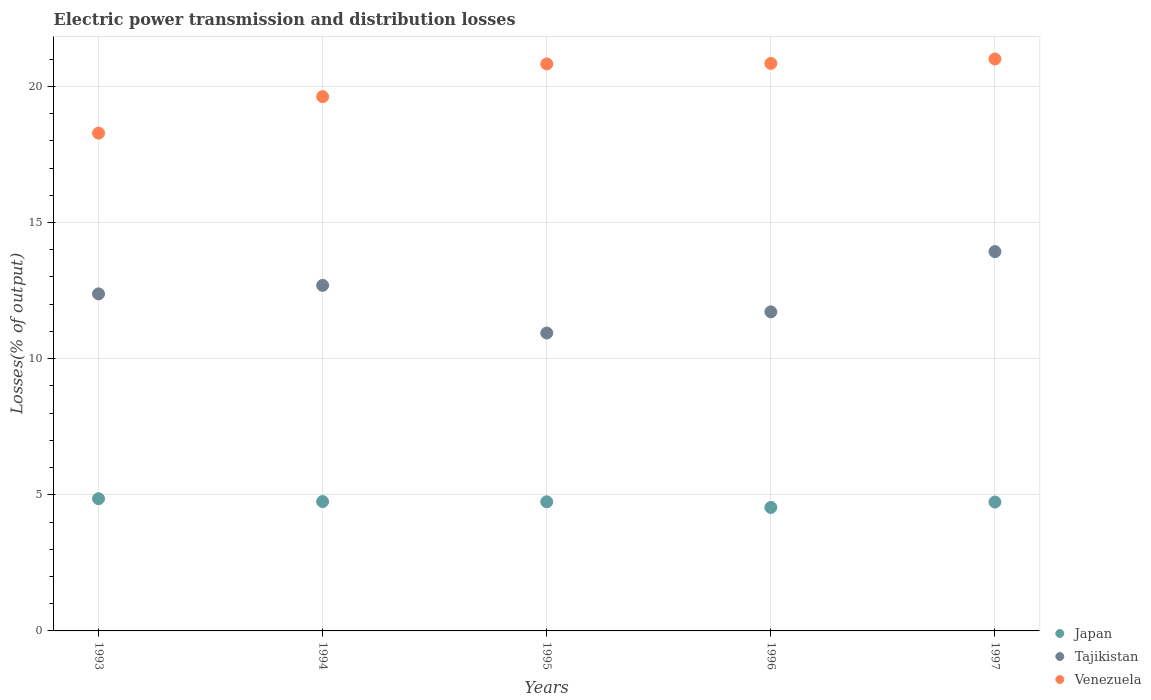How many different coloured dotlines are there?
Your response must be concise. 3. Is the number of dotlines equal to the number of legend labels?
Your response must be concise. Yes. What is the electric power transmission and distribution losses in Tajikistan in 1993?
Your answer should be compact. 12.38. Across all years, what is the maximum electric power transmission and distribution losses in Venezuela?
Provide a succinct answer. 21. Across all years, what is the minimum electric power transmission and distribution losses in Tajikistan?
Ensure brevity in your answer.  10.94. What is the total electric power transmission and distribution losses in Venezuela in the graph?
Offer a terse response. 100.57. What is the difference between the electric power transmission and distribution losses in Venezuela in 1994 and that in 1995?
Ensure brevity in your answer.  -1.2. What is the difference between the electric power transmission and distribution losses in Venezuela in 1993 and the electric power transmission and distribution losses in Tajikistan in 1997?
Keep it short and to the point. 4.35. What is the average electric power transmission and distribution losses in Tajikistan per year?
Make the answer very short. 12.33. In the year 1996, what is the difference between the electric power transmission and distribution losses in Venezuela and electric power transmission and distribution losses in Japan?
Give a very brief answer. 16.31. What is the ratio of the electric power transmission and distribution losses in Tajikistan in 1995 to that in 1996?
Your answer should be very brief. 0.93. Is the electric power transmission and distribution losses in Venezuela in 1994 less than that in 1997?
Your answer should be very brief. Yes. What is the difference between the highest and the second highest electric power transmission and distribution losses in Venezuela?
Give a very brief answer. 0.16. What is the difference between the highest and the lowest electric power transmission and distribution losses in Japan?
Your response must be concise. 0.32. In how many years, is the electric power transmission and distribution losses in Tajikistan greater than the average electric power transmission and distribution losses in Tajikistan taken over all years?
Your response must be concise. 3. Is the sum of the electric power transmission and distribution losses in Tajikistan in 1994 and 1996 greater than the maximum electric power transmission and distribution losses in Japan across all years?
Your response must be concise. Yes. How many dotlines are there?
Your response must be concise. 3. How many years are there in the graph?
Your answer should be very brief. 5. What is the difference between two consecutive major ticks on the Y-axis?
Ensure brevity in your answer.  5. Does the graph contain grids?
Provide a short and direct response. Yes. Where does the legend appear in the graph?
Your answer should be compact. Bottom right. How are the legend labels stacked?
Provide a short and direct response. Vertical. What is the title of the graph?
Your response must be concise. Electric power transmission and distribution losses. Does "Slovenia" appear as one of the legend labels in the graph?
Offer a terse response. No. What is the label or title of the X-axis?
Provide a succinct answer. Years. What is the label or title of the Y-axis?
Offer a very short reply. Losses(% of output). What is the Losses(% of output) of Japan in 1993?
Ensure brevity in your answer.  4.86. What is the Losses(% of output) in Tajikistan in 1993?
Provide a short and direct response. 12.38. What is the Losses(% of output) of Venezuela in 1993?
Ensure brevity in your answer.  18.28. What is the Losses(% of output) of Japan in 1994?
Offer a very short reply. 4.75. What is the Losses(% of output) of Tajikistan in 1994?
Provide a short and direct response. 12.69. What is the Losses(% of output) in Venezuela in 1994?
Provide a short and direct response. 19.62. What is the Losses(% of output) in Japan in 1995?
Your answer should be very brief. 4.74. What is the Losses(% of output) in Tajikistan in 1995?
Your answer should be very brief. 10.94. What is the Losses(% of output) in Venezuela in 1995?
Keep it short and to the point. 20.82. What is the Losses(% of output) of Japan in 1996?
Make the answer very short. 4.54. What is the Losses(% of output) in Tajikistan in 1996?
Ensure brevity in your answer.  11.72. What is the Losses(% of output) in Venezuela in 1996?
Your answer should be compact. 20.84. What is the Losses(% of output) of Japan in 1997?
Your response must be concise. 4.73. What is the Losses(% of output) in Tajikistan in 1997?
Your response must be concise. 13.93. What is the Losses(% of output) in Venezuela in 1997?
Make the answer very short. 21. Across all years, what is the maximum Losses(% of output) of Japan?
Offer a terse response. 4.86. Across all years, what is the maximum Losses(% of output) in Tajikistan?
Your answer should be very brief. 13.93. Across all years, what is the maximum Losses(% of output) of Venezuela?
Provide a short and direct response. 21. Across all years, what is the minimum Losses(% of output) in Japan?
Offer a terse response. 4.54. Across all years, what is the minimum Losses(% of output) in Tajikistan?
Give a very brief answer. 10.94. Across all years, what is the minimum Losses(% of output) in Venezuela?
Offer a terse response. 18.28. What is the total Losses(% of output) in Japan in the graph?
Your response must be concise. 23.62. What is the total Losses(% of output) in Tajikistan in the graph?
Your answer should be compact. 61.66. What is the total Losses(% of output) of Venezuela in the graph?
Keep it short and to the point. 100.57. What is the difference between the Losses(% of output) of Japan in 1993 and that in 1994?
Provide a short and direct response. 0.11. What is the difference between the Losses(% of output) of Tajikistan in 1993 and that in 1994?
Ensure brevity in your answer.  -0.31. What is the difference between the Losses(% of output) of Venezuela in 1993 and that in 1994?
Give a very brief answer. -1.34. What is the difference between the Losses(% of output) in Japan in 1993 and that in 1995?
Provide a short and direct response. 0.11. What is the difference between the Losses(% of output) in Tajikistan in 1993 and that in 1995?
Your answer should be very brief. 1.44. What is the difference between the Losses(% of output) in Venezuela in 1993 and that in 1995?
Offer a terse response. -2.54. What is the difference between the Losses(% of output) in Japan in 1993 and that in 1996?
Provide a succinct answer. 0.32. What is the difference between the Losses(% of output) in Tajikistan in 1993 and that in 1996?
Offer a terse response. 0.66. What is the difference between the Losses(% of output) in Venezuela in 1993 and that in 1996?
Your answer should be compact. -2.56. What is the difference between the Losses(% of output) of Japan in 1993 and that in 1997?
Make the answer very short. 0.12. What is the difference between the Losses(% of output) in Tajikistan in 1993 and that in 1997?
Ensure brevity in your answer.  -1.55. What is the difference between the Losses(% of output) in Venezuela in 1993 and that in 1997?
Offer a terse response. -2.72. What is the difference between the Losses(% of output) in Japan in 1994 and that in 1995?
Offer a very short reply. 0.01. What is the difference between the Losses(% of output) in Tajikistan in 1994 and that in 1995?
Provide a succinct answer. 1.75. What is the difference between the Losses(% of output) in Venezuela in 1994 and that in 1995?
Make the answer very short. -1.2. What is the difference between the Losses(% of output) of Japan in 1994 and that in 1996?
Provide a succinct answer. 0.21. What is the difference between the Losses(% of output) of Tajikistan in 1994 and that in 1996?
Keep it short and to the point. 0.97. What is the difference between the Losses(% of output) of Venezuela in 1994 and that in 1996?
Offer a terse response. -1.22. What is the difference between the Losses(% of output) of Japan in 1994 and that in 1997?
Your answer should be compact. 0.02. What is the difference between the Losses(% of output) of Tajikistan in 1994 and that in 1997?
Offer a terse response. -1.24. What is the difference between the Losses(% of output) of Venezuela in 1994 and that in 1997?
Offer a very short reply. -1.38. What is the difference between the Losses(% of output) of Japan in 1995 and that in 1996?
Provide a succinct answer. 0.21. What is the difference between the Losses(% of output) in Tajikistan in 1995 and that in 1996?
Provide a succinct answer. -0.78. What is the difference between the Losses(% of output) of Venezuela in 1995 and that in 1996?
Your response must be concise. -0.02. What is the difference between the Losses(% of output) of Japan in 1995 and that in 1997?
Offer a terse response. 0.01. What is the difference between the Losses(% of output) in Tajikistan in 1995 and that in 1997?
Ensure brevity in your answer.  -2.99. What is the difference between the Losses(% of output) of Venezuela in 1995 and that in 1997?
Provide a succinct answer. -0.18. What is the difference between the Losses(% of output) of Japan in 1996 and that in 1997?
Keep it short and to the point. -0.2. What is the difference between the Losses(% of output) of Tajikistan in 1996 and that in 1997?
Your response must be concise. -2.21. What is the difference between the Losses(% of output) in Venezuela in 1996 and that in 1997?
Your answer should be compact. -0.16. What is the difference between the Losses(% of output) of Japan in 1993 and the Losses(% of output) of Tajikistan in 1994?
Your response must be concise. -7.83. What is the difference between the Losses(% of output) of Japan in 1993 and the Losses(% of output) of Venezuela in 1994?
Offer a very short reply. -14.77. What is the difference between the Losses(% of output) in Tajikistan in 1993 and the Losses(% of output) in Venezuela in 1994?
Provide a succinct answer. -7.24. What is the difference between the Losses(% of output) of Japan in 1993 and the Losses(% of output) of Tajikistan in 1995?
Provide a succinct answer. -6.09. What is the difference between the Losses(% of output) of Japan in 1993 and the Losses(% of output) of Venezuela in 1995?
Offer a very short reply. -15.97. What is the difference between the Losses(% of output) of Tajikistan in 1993 and the Losses(% of output) of Venezuela in 1995?
Your response must be concise. -8.45. What is the difference between the Losses(% of output) in Japan in 1993 and the Losses(% of output) in Tajikistan in 1996?
Make the answer very short. -6.86. What is the difference between the Losses(% of output) of Japan in 1993 and the Losses(% of output) of Venezuela in 1996?
Your answer should be very brief. -15.99. What is the difference between the Losses(% of output) of Tajikistan in 1993 and the Losses(% of output) of Venezuela in 1996?
Make the answer very short. -8.46. What is the difference between the Losses(% of output) of Japan in 1993 and the Losses(% of output) of Tajikistan in 1997?
Offer a terse response. -9.08. What is the difference between the Losses(% of output) in Japan in 1993 and the Losses(% of output) in Venezuela in 1997?
Provide a short and direct response. -16.15. What is the difference between the Losses(% of output) of Tajikistan in 1993 and the Losses(% of output) of Venezuela in 1997?
Make the answer very short. -8.63. What is the difference between the Losses(% of output) of Japan in 1994 and the Losses(% of output) of Tajikistan in 1995?
Ensure brevity in your answer.  -6.19. What is the difference between the Losses(% of output) in Japan in 1994 and the Losses(% of output) in Venezuela in 1995?
Provide a succinct answer. -16.07. What is the difference between the Losses(% of output) in Tajikistan in 1994 and the Losses(% of output) in Venezuela in 1995?
Make the answer very short. -8.13. What is the difference between the Losses(% of output) of Japan in 1994 and the Losses(% of output) of Tajikistan in 1996?
Provide a short and direct response. -6.97. What is the difference between the Losses(% of output) of Japan in 1994 and the Losses(% of output) of Venezuela in 1996?
Provide a succinct answer. -16.09. What is the difference between the Losses(% of output) of Tajikistan in 1994 and the Losses(% of output) of Venezuela in 1996?
Provide a succinct answer. -8.15. What is the difference between the Losses(% of output) of Japan in 1994 and the Losses(% of output) of Tajikistan in 1997?
Offer a terse response. -9.18. What is the difference between the Losses(% of output) of Japan in 1994 and the Losses(% of output) of Venezuela in 1997?
Give a very brief answer. -16.25. What is the difference between the Losses(% of output) of Tajikistan in 1994 and the Losses(% of output) of Venezuela in 1997?
Make the answer very short. -8.31. What is the difference between the Losses(% of output) in Japan in 1995 and the Losses(% of output) in Tajikistan in 1996?
Give a very brief answer. -6.98. What is the difference between the Losses(% of output) of Japan in 1995 and the Losses(% of output) of Venezuela in 1996?
Ensure brevity in your answer.  -16.1. What is the difference between the Losses(% of output) in Tajikistan in 1995 and the Losses(% of output) in Venezuela in 1996?
Keep it short and to the point. -9.9. What is the difference between the Losses(% of output) in Japan in 1995 and the Losses(% of output) in Tajikistan in 1997?
Your response must be concise. -9.19. What is the difference between the Losses(% of output) in Japan in 1995 and the Losses(% of output) in Venezuela in 1997?
Offer a very short reply. -16.26. What is the difference between the Losses(% of output) in Tajikistan in 1995 and the Losses(% of output) in Venezuela in 1997?
Give a very brief answer. -10.06. What is the difference between the Losses(% of output) in Japan in 1996 and the Losses(% of output) in Tajikistan in 1997?
Your response must be concise. -9.4. What is the difference between the Losses(% of output) in Japan in 1996 and the Losses(% of output) in Venezuela in 1997?
Your response must be concise. -16.47. What is the difference between the Losses(% of output) in Tajikistan in 1996 and the Losses(% of output) in Venezuela in 1997?
Make the answer very short. -9.29. What is the average Losses(% of output) in Japan per year?
Make the answer very short. 4.72. What is the average Losses(% of output) of Tajikistan per year?
Provide a short and direct response. 12.33. What is the average Losses(% of output) of Venezuela per year?
Keep it short and to the point. 20.11. In the year 1993, what is the difference between the Losses(% of output) of Japan and Losses(% of output) of Tajikistan?
Your answer should be very brief. -7.52. In the year 1993, what is the difference between the Losses(% of output) in Japan and Losses(% of output) in Venezuela?
Your answer should be compact. -13.43. In the year 1993, what is the difference between the Losses(% of output) of Tajikistan and Losses(% of output) of Venezuela?
Provide a short and direct response. -5.9. In the year 1994, what is the difference between the Losses(% of output) in Japan and Losses(% of output) in Tajikistan?
Your answer should be compact. -7.94. In the year 1994, what is the difference between the Losses(% of output) in Japan and Losses(% of output) in Venezuela?
Your response must be concise. -14.87. In the year 1994, what is the difference between the Losses(% of output) of Tajikistan and Losses(% of output) of Venezuela?
Your answer should be very brief. -6.93. In the year 1995, what is the difference between the Losses(% of output) in Japan and Losses(% of output) in Tajikistan?
Your answer should be very brief. -6.2. In the year 1995, what is the difference between the Losses(% of output) in Japan and Losses(% of output) in Venezuela?
Your response must be concise. -16.08. In the year 1995, what is the difference between the Losses(% of output) in Tajikistan and Losses(% of output) in Venezuela?
Make the answer very short. -9.88. In the year 1996, what is the difference between the Losses(% of output) of Japan and Losses(% of output) of Tajikistan?
Give a very brief answer. -7.18. In the year 1996, what is the difference between the Losses(% of output) of Japan and Losses(% of output) of Venezuela?
Give a very brief answer. -16.31. In the year 1996, what is the difference between the Losses(% of output) in Tajikistan and Losses(% of output) in Venezuela?
Offer a very short reply. -9.12. In the year 1997, what is the difference between the Losses(% of output) in Japan and Losses(% of output) in Tajikistan?
Your answer should be compact. -9.2. In the year 1997, what is the difference between the Losses(% of output) in Japan and Losses(% of output) in Venezuela?
Ensure brevity in your answer.  -16.27. In the year 1997, what is the difference between the Losses(% of output) in Tajikistan and Losses(% of output) in Venezuela?
Keep it short and to the point. -7.07. What is the ratio of the Losses(% of output) in Japan in 1993 to that in 1994?
Give a very brief answer. 1.02. What is the ratio of the Losses(% of output) in Tajikistan in 1993 to that in 1994?
Provide a succinct answer. 0.98. What is the ratio of the Losses(% of output) in Venezuela in 1993 to that in 1994?
Your response must be concise. 0.93. What is the ratio of the Losses(% of output) in Japan in 1993 to that in 1995?
Keep it short and to the point. 1.02. What is the ratio of the Losses(% of output) in Tajikistan in 1993 to that in 1995?
Your response must be concise. 1.13. What is the ratio of the Losses(% of output) of Venezuela in 1993 to that in 1995?
Your answer should be compact. 0.88. What is the ratio of the Losses(% of output) in Japan in 1993 to that in 1996?
Make the answer very short. 1.07. What is the ratio of the Losses(% of output) in Tajikistan in 1993 to that in 1996?
Your answer should be very brief. 1.06. What is the ratio of the Losses(% of output) of Venezuela in 1993 to that in 1996?
Provide a short and direct response. 0.88. What is the ratio of the Losses(% of output) in Japan in 1993 to that in 1997?
Your response must be concise. 1.03. What is the ratio of the Losses(% of output) of Tajikistan in 1993 to that in 1997?
Provide a succinct answer. 0.89. What is the ratio of the Losses(% of output) in Venezuela in 1993 to that in 1997?
Keep it short and to the point. 0.87. What is the ratio of the Losses(% of output) in Tajikistan in 1994 to that in 1995?
Make the answer very short. 1.16. What is the ratio of the Losses(% of output) in Venezuela in 1994 to that in 1995?
Provide a short and direct response. 0.94. What is the ratio of the Losses(% of output) in Japan in 1994 to that in 1996?
Provide a succinct answer. 1.05. What is the ratio of the Losses(% of output) in Tajikistan in 1994 to that in 1996?
Your answer should be compact. 1.08. What is the ratio of the Losses(% of output) of Venezuela in 1994 to that in 1996?
Keep it short and to the point. 0.94. What is the ratio of the Losses(% of output) in Tajikistan in 1994 to that in 1997?
Your answer should be compact. 0.91. What is the ratio of the Losses(% of output) in Venezuela in 1994 to that in 1997?
Make the answer very short. 0.93. What is the ratio of the Losses(% of output) in Japan in 1995 to that in 1996?
Provide a short and direct response. 1.05. What is the ratio of the Losses(% of output) in Tajikistan in 1995 to that in 1996?
Keep it short and to the point. 0.93. What is the ratio of the Losses(% of output) in Japan in 1995 to that in 1997?
Your answer should be very brief. 1. What is the ratio of the Losses(% of output) in Tajikistan in 1995 to that in 1997?
Your answer should be very brief. 0.79. What is the ratio of the Losses(% of output) in Japan in 1996 to that in 1997?
Ensure brevity in your answer.  0.96. What is the ratio of the Losses(% of output) of Tajikistan in 1996 to that in 1997?
Provide a short and direct response. 0.84. What is the difference between the highest and the second highest Losses(% of output) in Japan?
Your response must be concise. 0.11. What is the difference between the highest and the second highest Losses(% of output) of Tajikistan?
Keep it short and to the point. 1.24. What is the difference between the highest and the second highest Losses(% of output) in Venezuela?
Ensure brevity in your answer.  0.16. What is the difference between the highest and the lowest Losses(% of output) of Japan?
Provide a short and direct response. 0.32. What is the difference between the highest and the lowest Losses(% of output) of Tajikistan?
Offer a very short reply. 2.99. What is the difference between the highest and the lowest Losses(% of output) in Venezuela?
Offer a very short reply. 2.72. 